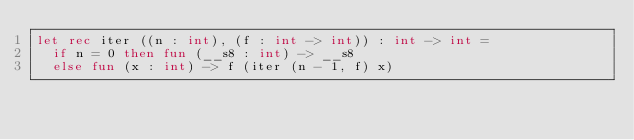Convert code to text. <code><loc_0><loc_0><loc_500><loc_500><_OCaml_>let rec iter ((n : int), (f : int -> int)) : int -> int =
  if n = 0 then fun (__s8 : int) -> __s8
  else fun (x : int) -> f (iter (n - 1, f) x)
</code> 